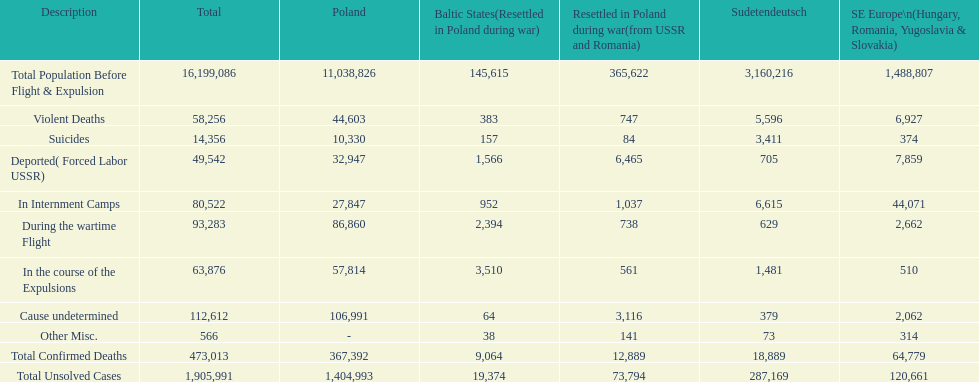In which nation was the death toll higher? Poland. 